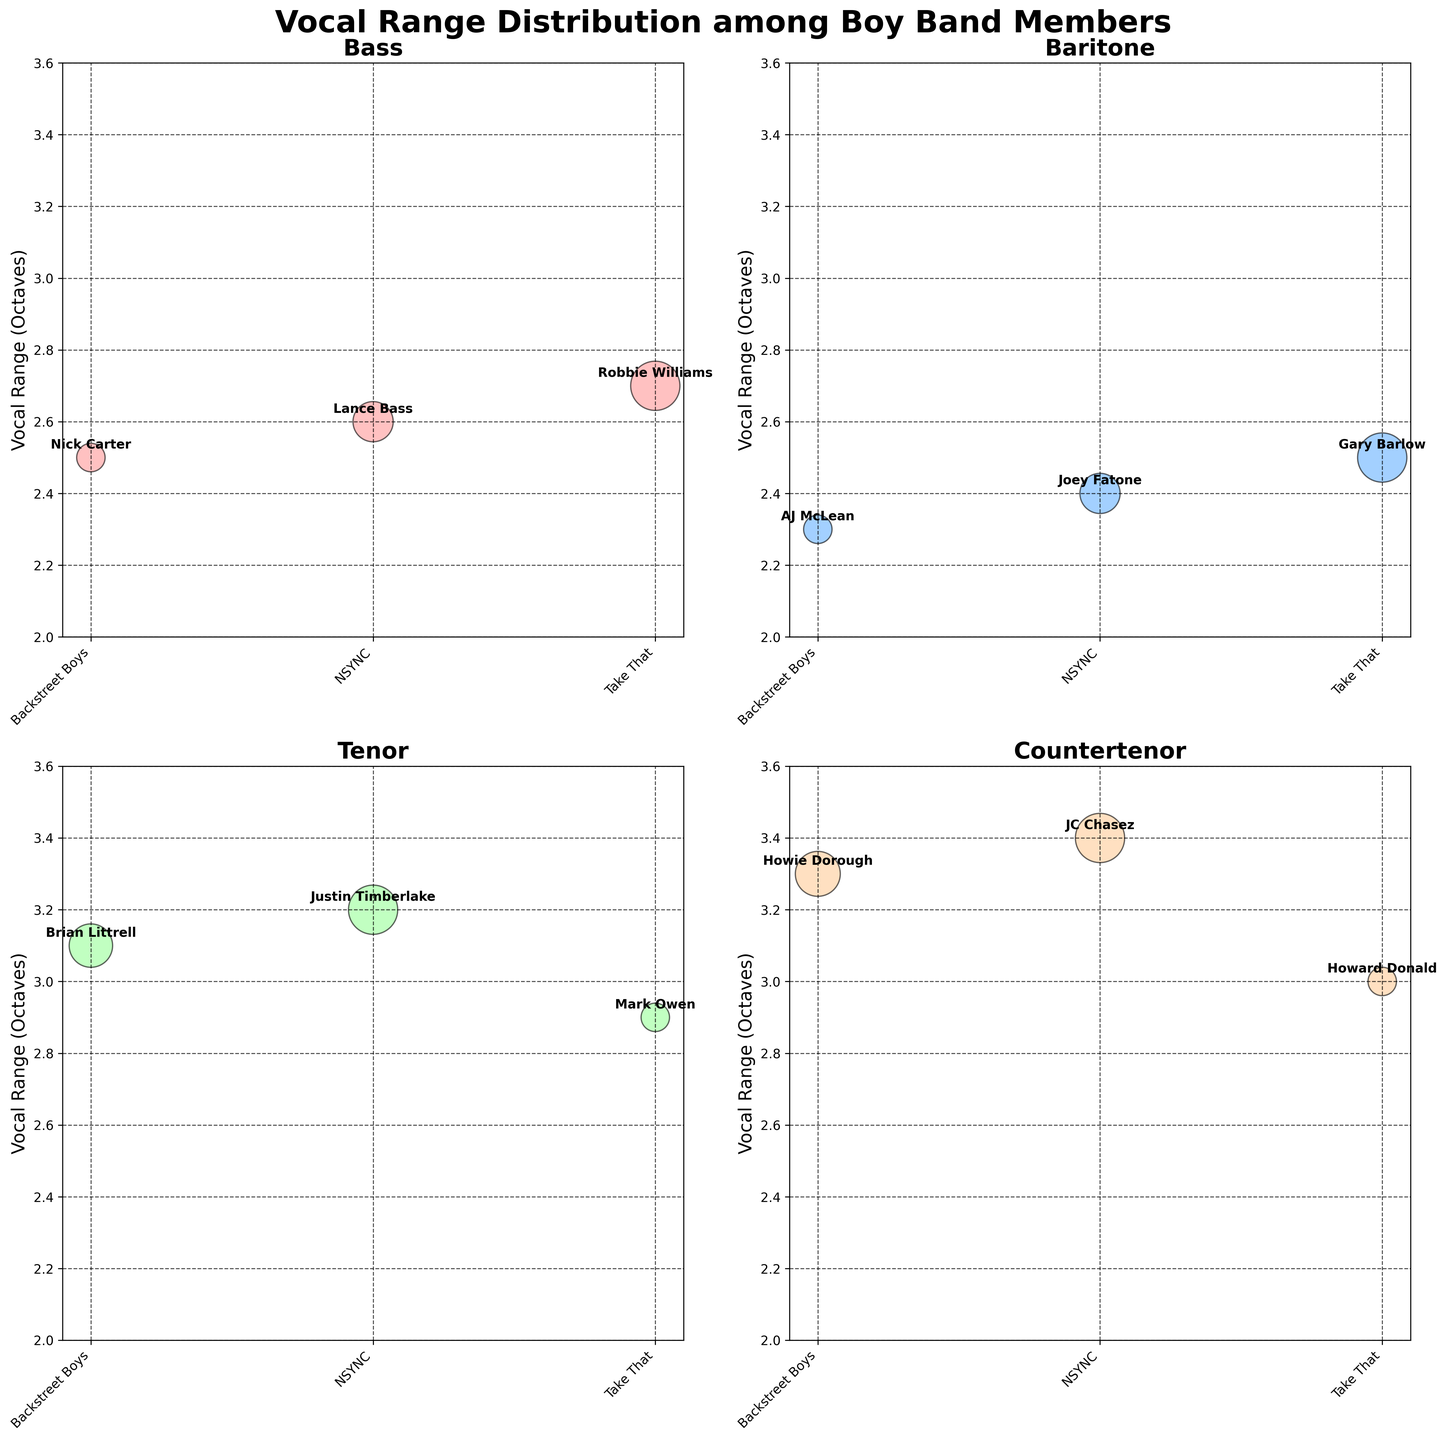What's the title of the overall figure? The title of the overall figure is typically placed at the top and is often the largest text. Here, it reads "Vocal Range Distribution among Boy Band Members".
Answer: Vocal Range Distribution among Boy Band Members How many voice types are displayed in the figure? The figure has four subplots, each titled after a different voice type. These titles are Bass, Baritone, Tenor, and Countertenor.
Answer: 4 Which member of Take That has the highest vocal range? In the subplot for the Countertenor voice type, Howard Donald from Take That has a vocal range of 3.0 octaves, which is the highest among Take That members.
Answer: Howard Donald Who has the smallest vocal range among the Baritones? In the subplot for the Baritone voice type, AJ McLean and Joey Fatone have vocal ranges of 2.3 and 2.4 octaves respectively, with AJ McLean having the smallest range.
Answer: AJ McLean Which voice type has the highest overall vocal range, and which band does this member belong to? The "Countertenor" subplot shows the highest vocal range, with JC Chasez from NSYNC having a vocal range of 3.4 octaves.
Answer: Countertenor, NSYNC What is the range of vocal ranges displayed on the y-axis in all subplots? The y-axis in all subplots ranges from 2 to 3.6 octaves, as indicated by the labels and limits along the y-axes.
Answer: 2 to 3.6 octaves What color is used to represent the data points for Tenors? The color associated with Tenors, as seen in their subplot, is light green. This can be identified by observing the bubble color used to represent members within that subplot.
Answer: Light green How many members have vocal ranges above 3.0 octaves? In the Tenor subplot, Brian Littrell and Justin Timberlake have vocal ranges above 3.0 octaves (3.1 and 3.2 respectively), and in the Countertenor subplot, Howie Dorough and JC Chasez have vocal ranges above 3.0 octaves (3.3 and 3.4 respectively). So, there are 4 members with vocal ranges above 3.0 octaves.
Answer: 4 Which subplot displays the most diverse range in vocal ranges and why? The Tenor subplot has a visible range from 2.9 to 3.2 octaves, but the Countertenor subplot ranges from 3.0 to 3.4 octaves. The Countertenor subplot thus displays a more extensive range of 0.4 octaves, demonstrating the most diversity.
Answer: Countertenor Who has the largest bubble size in the Bass voice type, and what does this indicate? In the Bass subplot, Robbie Williams (Take That) has the largest bubble size due to his vocal range being 2.7 octaves, which is the highest among the Basses, indicating a broader vocal range.
Answer: Robbie Williams, broader vocal range 